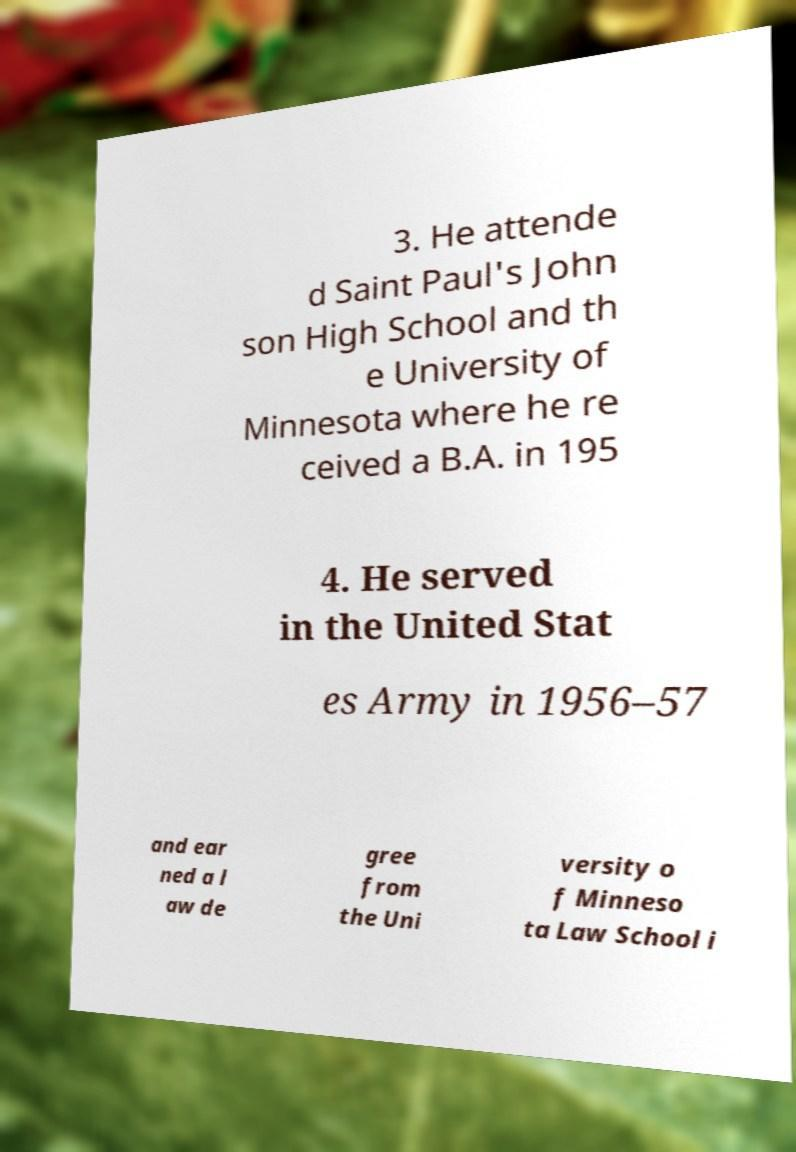Could you extract and type out the text from this image? 3. He attende d Saint Paul's John son High School and th e University of Minnesota where he re ceived a B.A. in 195 4. He served in the United Stat es Army in 1956–57 and ear ned a l aw de gree from the Uni versity o f Minneso ta Law School i 